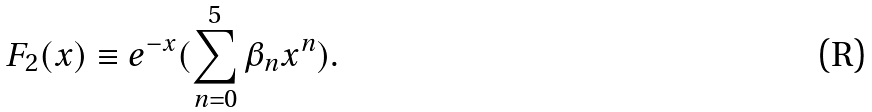<formula> <loc_0><loc_0><loc_500><loc_500>F _ { 2 } ( x ) \equiv e ^ { - x } ( \sum _ { n = 0 } ^ { 5 } \beta _ { n } x ^ { n } ) .</formula> 